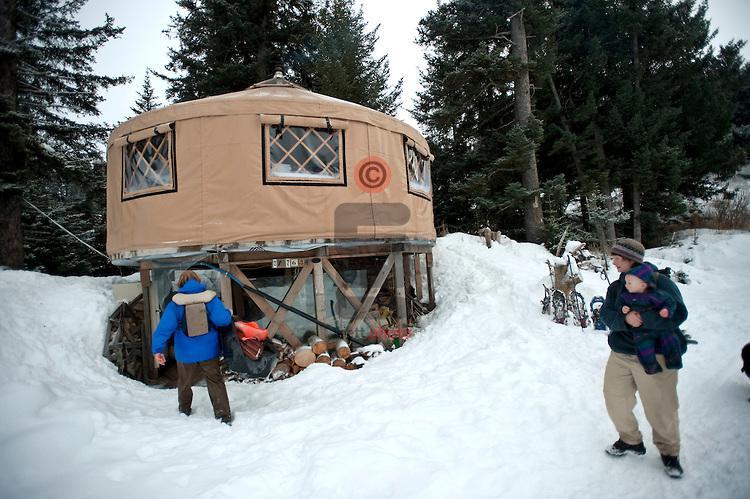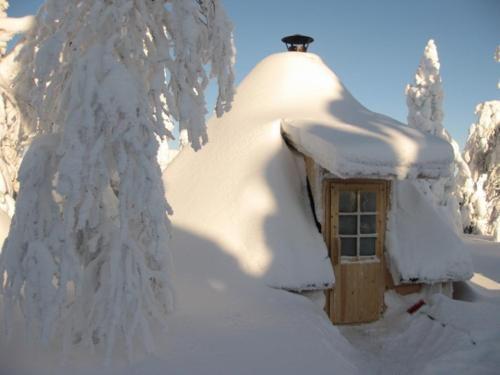The first image is the image on the left, the second image is the image on the right. Evaluate the accuracy of this statement regarding the images: "At least one image shows a building in a snowy setting.". Is it true? Answer yes or no. Yes. The first image is the image on the left, the second image is the image on the right. Evaluate the accuracy of this statement regarding the images: "Both images are interior shots of round houses.". Is it true? Answer yes or no. No. 